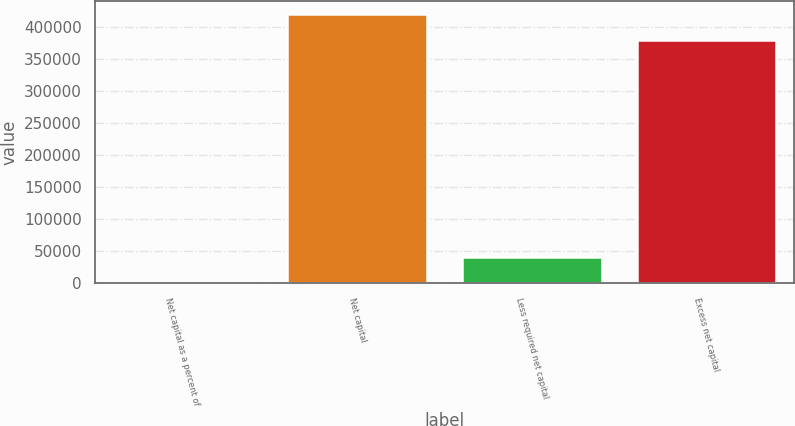Convert chart to OTSL. <chart><loc_0><loc_0><loc_500><loc_500><bar_chart><fcel>Net capital as a percent of<fcel>Net capital<fcel>Less required net capital<fcel>Excess net capital<nl><fcel>27.02<fcel>420513<fcel>41011.2<fcel>379529<nl></chart> 